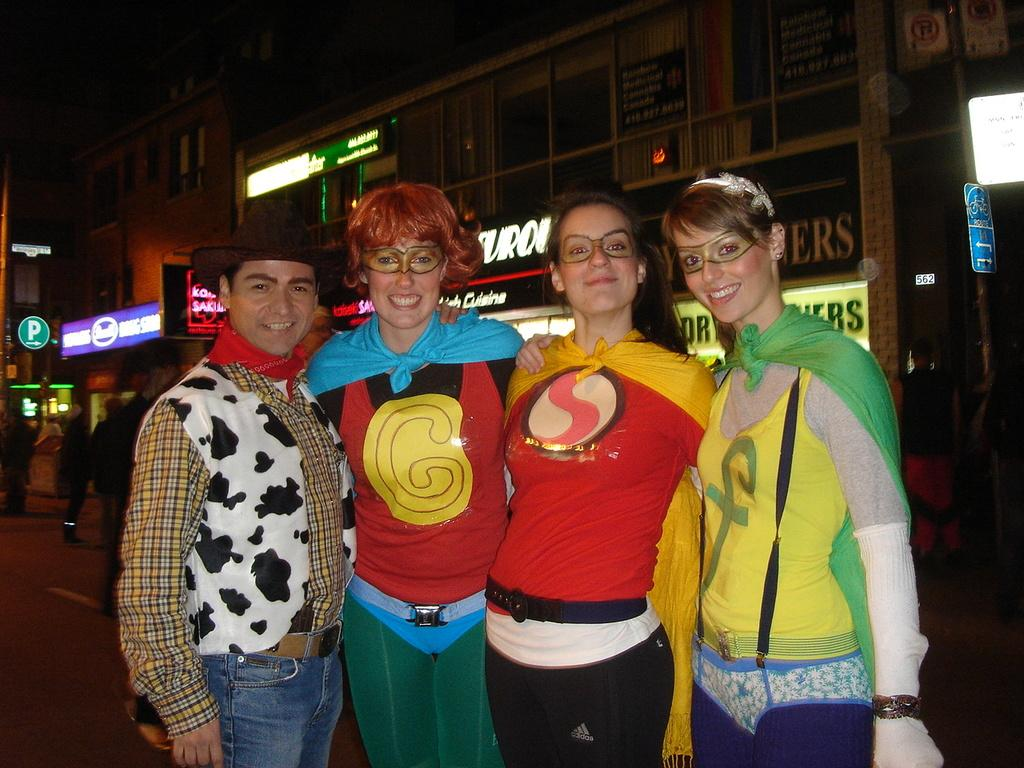What can be seen in the image? There are people standing in the image. What is visible in the background of the image? There are buildings and boards visible in the background of the image. What type of jewel is being worn by the people in the image? There is no mention of any jewelry or jewels being worn by the people in the image. 